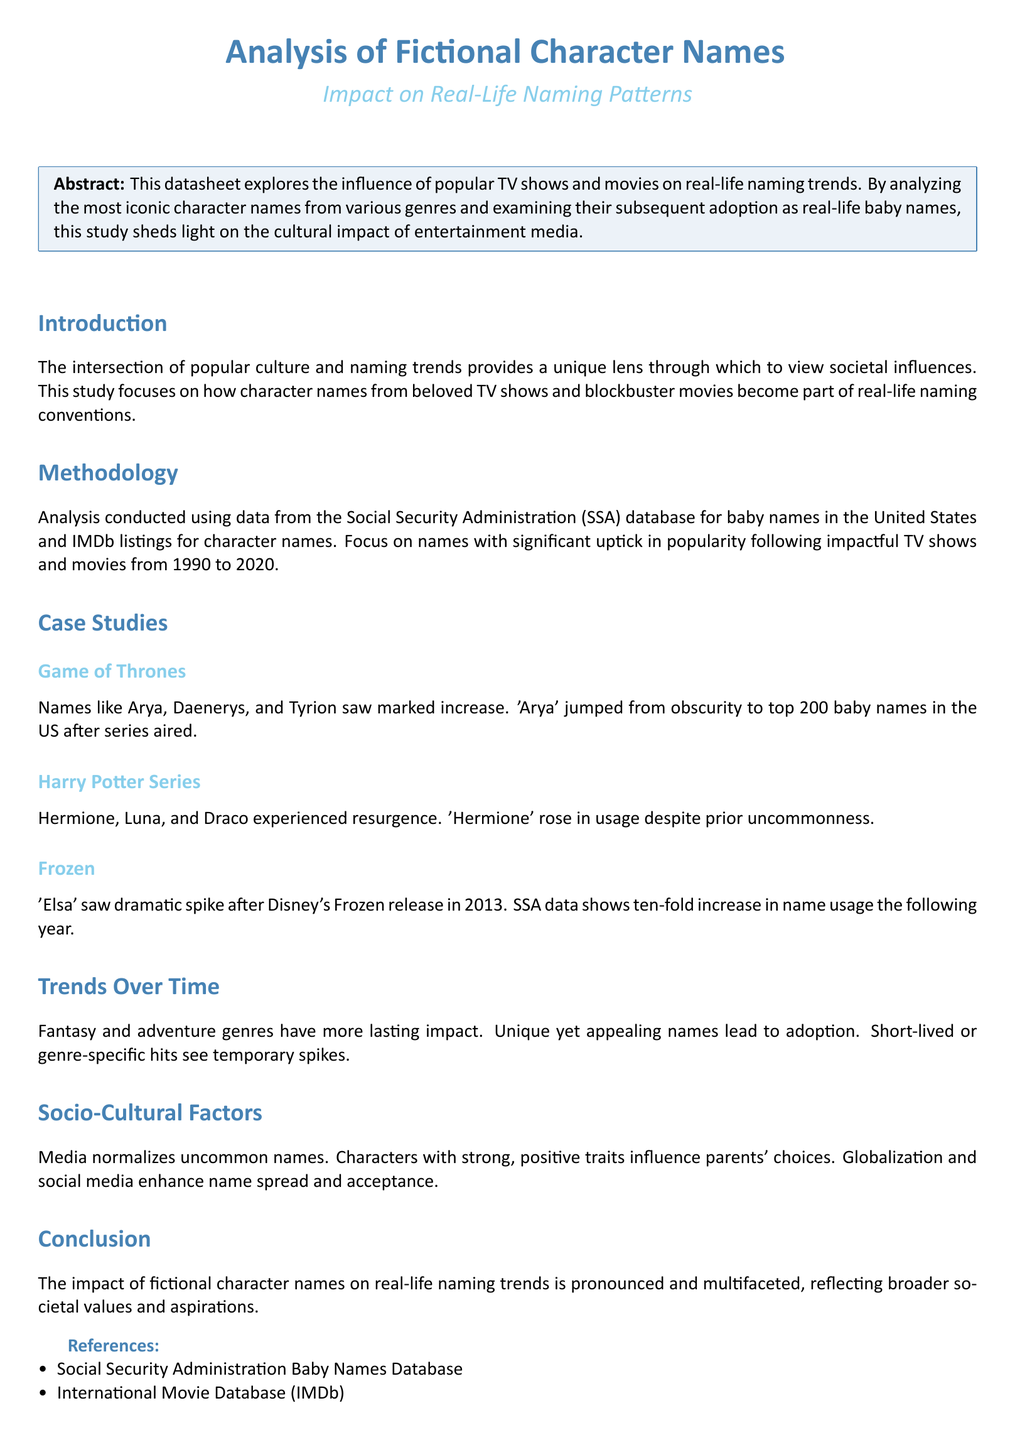What is the time period analyzed in this study? The study spans from 1990 to 2020, focusing on naming trends during this interval.
Answer: 1990 to 2020 Which TV show led to a spike in the name 'Arya'? The spike in the name 'Arya' is attributed to the popular TV show "Game of Thrones."
Answer: Game of Thrones What character name saw a ten-fold increase after the release of Frozen? The name that experienced a dramatic spike after "Frozen" was 'Elsa.'
Answer: Elsa What type of names lead to longer-term adoption as indicated in the trends? The document indicates that unique yet appealing names lead to longer-term adoption.
Answer: Unique yet appealing names Who is the author of the reference discussing the Harry Potter effect on baby names? The author of the reference is D. Johnson.
Answer: D. Johnson What does media normalize according to the socio-cultural factors section? Media normalizes uncommon names.
Answer: Uncommon names Which character from the Harry Potter Series saw a resurgence in usage? 'Hermione' is one of the names from the Harry Potter Series that saw a resurgence.
Answer: Hermione What aspect does the conclusion highlight about the impact of fictional character names? The conclusion emphasizes that the impact reflects broader societal values and aspirations.
Answer: Broader societal values and aspirations 